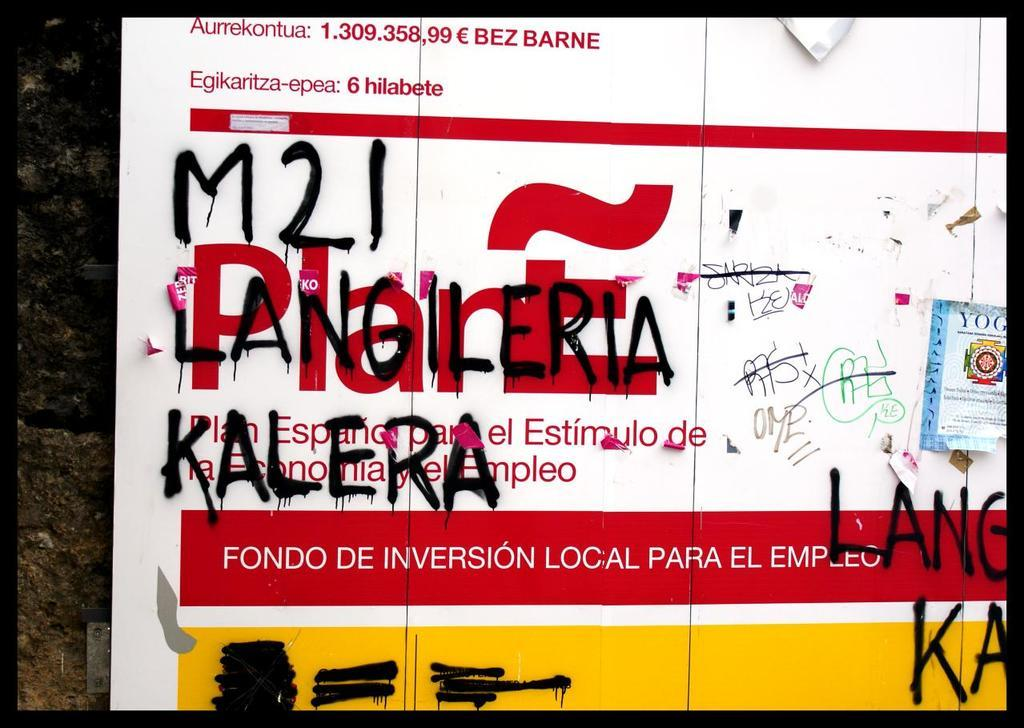Provide a one-sentence caption for the provided image. Advertisement outside with graffitti written over the advertisement that says '121 LANGILERIA KALERA.'. 